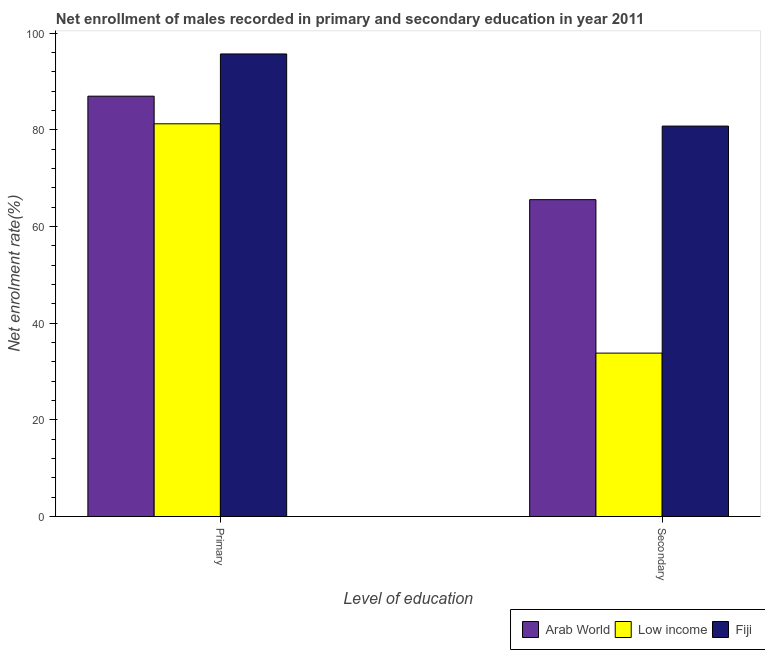How many different coloured bars are there?
Your answer should be very brief. 3. How many groups of bars are there?
Make the answer very short. 2. Are the number of bars on each tick of the X-axis equal?
Provide a short and direct response. Yes. How many bars are there on the 2nd tick from the right?
Provide a succinct answer. 3. What is the label of the 2nd group of bars from the left?
Your answer should be very brief. Secondary. What is the enrollment rate in secondary education in Fiji?
Keep it short and to the point. 80.76. Across all countries, what is the maximum enrollment rate in primary education?
Provide a short and direct response. 95.68. Across all countries, what is the minimum enrollment rate in secondary education?
Offer a very short reply. 33.8. In which country was the enrollment rate in secondary education maximum?
Make the answer very short. Fiji. What is the total enrollment rate in secondary education in the graph?
Your answer should be compact. 180.11. What is the difference between the enrollment rate in primary education in Arab World and that in Fiji?
Ensure brevity in your answer.  -8.73. What is the difference between the enrollment rate in primary education in Arab World and the enrollment rate in secondary education in Low income?
Provide a short and direct response. 53.15. What is the average enrollment rate in primary education per country?
Your response must be concise. 87.96. What is the difference between the enrollment rate in secondary education and enrollment rate in primary education in Fiji?
Make the answer very short. -14.92. What is the ratio of the enrollment rate in secondary education in Fiji to that in Low income?
Provide a succinct answer. 2.39. Is the enrollment rate in secondary education in Low income less than that in Arab World?
Provide a short and direct response. Yes. In how many countries, is the enrollment rate in secondary education greater than the average enrollment rate in secondary education taken over all countries?
Offer a terse response. 2. What does the 3rd bar from the left in Primary represents?
Keep it short and to the point. Fiji. What does the 3rd bar from the right in Primary represents?
Ensure brevity in your answer.  Arab World. Are the values on the major ticks of Y-axis written in scientific E-notation?
Keep it short and to the point. No. Where does the legend appear in the graph?
Make the answer very short. Bottom right. How are the legend labels stacked?
Your answer should be very brief. Horizontal. What is the title of the graph?
Offer a very short reply. Net enrollment of males recorded in primary and secondary education in year 2011. What is the label or title of the X-axis?
Ensure brevity in your answer.  Level of education. What is the label or title of the Y-axis?
Your answer should be compact. Net enrolment rate(%). What is the Net enrolment rate(%) of Arab World in Primary?
Make the answer very short. 86.95. What is the Net enrolment rate(%) in Low income in Primary?
Keep it short and to the point. 81.23. What is the Net enrolment rate(%) in Fiji in Primary?
Your answer should be compact. 95.68. What is the Net enrolment rate(%) in Arab World in Secondary?
Give a very brief answer. 65.55. What is the Net enrolment rate(%) in Low income in Secondary?
Offer a very short reply. 33.8. What is the Net enrolment rate(%) in Fiji in Secondary?
Provide a succinct answer. 80.76. Across all Level of education, what is the maximum Net enrolment rate(%) in Arab World?
Provide a short and direct response. 86.95. Across all Level of education, what is the maximum Net enrolment rate(%) of Low income?
Make the answer very short. 81.23. Across all Level of education, what is the maximum Net enrolment rate(%) of Fiji?
Your answer should be compact. 95.68. Across all Level of education, what is the minimum Net enrolment rate(%) in Arab World?
Make the answer very short. 65.55. Across all Level of education, what is the minimum Net enrolment rate(%) in Low income?
Keep it short and to the point. 33.8. Across all Level of education, what is the minimum Net enrolment rate(%) in Fiji?
Offer a terse response. 80.76. What is the total Net enrolment rate(%) in Arab World in the graph?
Keep it short and to the point. 152.5. What is the total Net enrolment rate(%) of Low income in the graph?
Offer a very short reply. 115.03. What is the total Net enrolment rate(%) in Fiji in the graph?
Provide a succinct answer. 176.45. What is the difference between the Net enrolment rate(%) of Arab World in Primary and that in Secondary?
Your answer should be very brief. 21.4. What is the difference between the Net enrolment rate(%) of Low income in Primary and that in Secondary?
Your answer should be very brief. 47.43. What is the difference between the Net enrolment rate(%) of Fiji in Primary and that in Secondary?
Your answer should be very brief. 14.92. What is the difference between the Net enrolment rate(%) of Arab World in Primary and the Net enrolment rate(%) of Low income in Secondary?
Provide a succinct answer. 53.15. What is the difference between the Net enrolment rate(%) of Arab World in Primary and the Net enrolment rate(%) of Fiji in Secondary?
Ensure brevity in your answer.  6.19. What is the difference between the Net enrolment rate(%) of Low income in Primary and the Net enrolment rate(%) of Fiji in Secondary?
Provide a succinct answer. 0.47. What is the average Net enrolment rate(%) of Arab World per Level of education?
Keep it short and to the point. 76.25. What is the average Net enrolment rate(%) in Low income per Level of education?
Your answer should be compact. 57.52. What is the average Net enrolment rate(%) in Fiji per Level of education?
Keep it short and to the point. 88.22. What is the difference between the Net enrolment rate(%) in Arab World and Net enrolment rate(%) in Low income in Primary?
Provide a short and direct response. 5.72. What is the difference between the Net enrolment rate(%) in Arab World and Net enrolment rate(%) in Fiji in Primary?
Your answer should be very brief. -8.73. What is the difference between the Net enrolment rate(%) of Low income and Net enrolment rate(%) of Fiji in Primary?
Offer a terse response. -14.45. What is the difference between the Net enrolment rate(%) in Arab World and Net enrolment rate(%) in Low income in Secondary?
Your answer should be compact. 31.74. What is the difference between the Net enrolment rate(%) of Arab World and Net enrolment rate(%) of Fiji in Secondary?
Make the answer very short. -15.22. What is the difference between the Net enrolment rate(%) in Low income and Net enrolment rate(%) in Fiji in Secondary?
Offer a terse response. -46.96. What is the ratio of the Net enrolment rate(%) in Arab World in Primary to that in Secondary?
Offer a very short reply. 1.33. What is the ratio of the Net enrolment rate(%) in Low income in Primary to that in Secondary?
Keep it short and to the point. 2.4. What is the ratio of the Net enrolment rate(%) of Fiji in Primary to that in Secondary?
Your response must be concise. 1.18. What is the difference between the highest and the second highest Net enrolment rate(%) in Arab World?
Keep it short and to the point. 21.4. What is the difference between the highest and the second highest Net enrolment rate(%) of Low income?
Your response must be concise. 47.43. What is the difference between the highest and the second highest Net enrolment rate(%) of Fiji?
Keep it short and to the point. 14.92. What is the difference between the highest and the lowest Net enrolment rate(%) in Arab World?
Keep it short and to the point. 21.4. What is the difference between the highest and the lowest Net enrolment rate(%) of Low income?
Make the answer very short. 47.43. What is the difference between the highest and the lowest Net enrolment rate(%) of Fiji?
Make the answer very short. 14.92. 